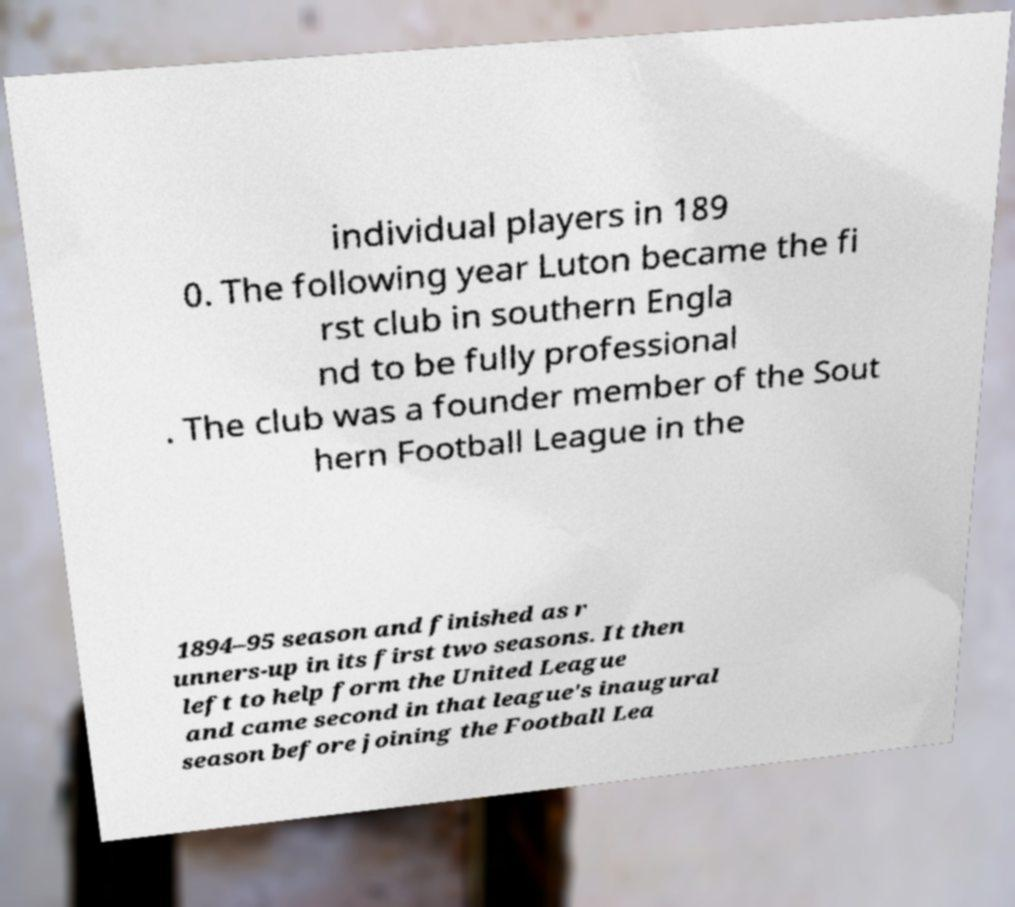Could you assist in decoding the text presented in this image and type it out clearly? individual players in 189 0. The following year Luton became the fi rst club in southern Engla nd to be fully professional . The club was a founder member of the Sout hern Football League in the 1894–95 season and finished as r unners-up in its first two seasons. It then left to help form the United League and came second in that league's inaugural season before joining the Football Lea 